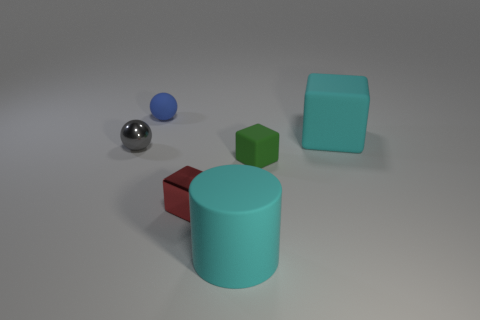Add 4 big yellow objects. How many objects exist? 10 Subtract all cylinders. How many objects are left? 5 Subtract all big gray matte spheres. Subtract all gray metallic spheres. How many objects are left? 5 Add 4 blue things. How many blue things are left? 5 Add 4 big purple matte spheres. How many big purple matte spheres exist? 4 Subtract 0 purple balls. How many objects are left? 6 